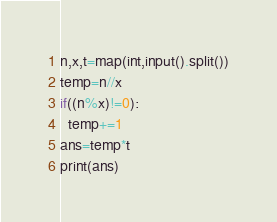<code> <loc_0><loc_0><loc_500><loc_500><_Python_>n,x,t=map(int,input().split())
temp=n//x
if((n%x)!=0):
  temp+=1
ans=temp*t
print(ans)</code> 